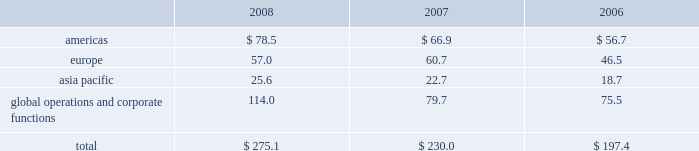Depreciation and amortization included in operating segment profit for the years ended december 31 , 2008 , 2007 and 2006 was as follows ( in millions ) : .
15 .
Leases future minimum rental commitments under non- cancelable operating leases in effect as of december 31 , 2008 were $ 38.2 million for 2009 , $ 30.1 million for 2010 , $ 20.9 million for 2011 , $ 15.9 million for 2012 , $ 14.3 million for 2013 and $ 29.9 million thereafter .
Total rent expense for the years ended december 31 , 2008 , 2007 and 2006 aggregated $ 41.4 million , $ 37.1 million and $ 31.1 million , respectively .
16 .
Commitments and contingencies intellectual property and product liability-related litigation in july 2008 , we temporarily suspended marketing and distribution of the durom bb acetabular component ( durom cup ) in the u.s .
To allow us to update product labeling to provide more detailed surgical technique instructions to surgeons and implement a surgical training program in the u.s .
Following our announcement , product liability lawsuits and other claims have been asserted against us , some of which we have settled .
There are a number of claims still pending and we expect additional claims will be submitted .
We recorded a provision of $ 47.5 million in the third quarter of 2008 , representing management 2019s estimate of these durom cup-related claims .
We increased that provision by $ 21.5 million in the fourth quarter of 2008 .
The provision is limited to revisions within two years of an original surgery that occurred prior to july 2008 .
These parameters are consistent with our data which indicates that cup loosenings associated with surgical technique are most likely to occur within that time period .
Any claims received outside of these defined parameters will be managed in the normal course and reflected in our standard product liability accruals .
On february 15 , 2005 , howmedica osteonics corp .
Filed an action against us and an unrelated party in the united states district court for the district of new jersey alleging infringement of u.s .
Patent nos .
6174934 ; 6372814 ; 6664308 ; and 6818020 .
On june 13 , 2007 , the court granted our motion for summary judgment on the invalidity of the asserted claims of u.s .
Patent nos .
6174934 ; 6372814 ; and 6664308 by ruling that all of the asserted claims are invalid for indefiniteness .
On august 19 , 2008 , the court granted our motion for summary judgment of non- infringement of certain claims of u.s .
Patent no .
6818020 , reducing the number of claims at issue in the suit to five .
We continue to believe that our defenses against infringement of the remaining claims are valid and meritorious , and we intend to defend this lawsuit vigorously .
In addition to certain claims related to the durom cup discussed above , we are also subject to product liability and other claims and lawsuits arising in the ordinary course of business , for which we maintain insurance , subject to self- insured retention limits .
We establish accruals for product liability and other claims in conjunction with outside counsel based on current information and historical settlement information for open claims , related fees and claims incurred but not reported .
While it is not possible to predict with certainty the outcome of these cases , it is the opinion of management that , upon ultimate resolution , liabilities from these cases in excess of those recorded , if any , will not have a material adverse effect on our consolidated financial position , results of operations or cash flows .
Government investigations in march 2005 , the u.s .
Department of justice through the u.s .
Attorney 2019s office in newark , new jersey commenced an investigation of us and four other orthopaedic companies pertaining to consulting contracts , professional service agreements and other agreements by which remuneration is provided to orthopaedic surgeons .
On september 27 , 2007 , we reached a settlement with the government to resolve all claims related to this investigation .
As part of the settlement , we entered into a settlement agreement with the u.s .
Through the u.s .
Department of justice and the office of inspector general of the department of health and human services ( the 201coig-hhs 201d ) .
In addition , we entered into a deferred prosecution agreement ( the 201cdpa 201d ) with the u.s .
Attorney 2019s office for the district of new jersey ( the 201cu.s .
Attorney 201d ) and a corporate integrity agreement ( the 201ccia 201d ) with the oig- hhs .
We did not admit any wrongdoing , plead guilty to any criminal charges or pay any criminal fines as part of the settlement .
We settled all civil and administrative claims related to the federal investigation by making a settlement payment to the u.s .
Government of $ 169.5 million .
Under the terms of the dpa , the u.s .
Attorney filed a criminal complaint in the u.s .
District court for the district of new jersey charging us with conspiracy to commit violations of the anti-kickback statute ( 42 u.s.c .
A7 1320a-7b ) during the years 2002 through 2006 .
The court deferred prosecution of the criminal complaint during the 18-month term of the dpa .
The u.s .
Attorney will seek dismissal of the criminal complaint after the 18-month period if we comply with the provisions of the dpa .
The dpa provides for oversight by a federally-appointed monitor .
Under the cia , which has a term of five years , we agreed , among other provisions , to continue the operation of our enhanced corporate compliance program , designed to promote compliance with federal healthcare program z i m m e r h o l d i n g s , i n c .
2 0 0 8 f o r m 1 0 - k a n n u a l r e p o r t notes to consolidated financial statements ( continued ) %%transmsg*** transmitting job : c48761 pcn : 060000000 ***%%pcmsg|60 |00012|yes|no|02/24/2009 06:10|0|0|page is valid , no graphics -- color : d| .
What was the percentage change in total rent expense from 2007 to 2008? 
Computations: ((41.4 - 37.1) / 37.1)
Answer: 0.1159. Depreciation and amortization included in operating segment profit for the years ended december 31 , 2008 , 2007 and 2006 was as follows ( in millions ) : .
15 .
Leases future minimum rental commitments under non- cancelable operating leases in effect as of december 31 , 2008 were $ 38.2 million for 2009 , $ 30.1 million for 2010 , $ 20.9 million for 2011 , $ 15.9 million for 2012 , $ 14.3 million for 2013 and $ 29.9 million thereafter .
Total rent expense for the years ended december 31 , 2008 , 2007 and 2006 aggregated $ 41.4 million , $ 37.1 million and $ 31.1 million , respectively .
16 .
Commitments and contingencies intellectual property and product liability-related litigation in july 2008 , we temporarily suspended marketing and distribution of the durom bb acetabular component ( durom cup ) in the u.s .
To allow us to update product labeling to provide more detailed surgical technique instructions to surgeons and implement a surgical training program in the u.s .
Following our announcement , product liability lawsuits and other claims have been asserted against us , some of which we have settled .
There are a number of claims still pending and we expect additional claims will be submitted .
We recorded a provision of $ 47.5 million in the third quarter of 2008 , representing management 2019s estimate of these durom cup-related claims .
We increased that provision by $ 21.5 million in the fourth quarter of 2008 .
The provision is limited to revisions within two years of an original surgery that occurred prior to july 2008 .
These parameters are consistent with our data which indicates that cup loosenings associated with surgical technique are most likely to occur within that time period .
Any claims received outside of these defined parameters will be managed in the normal course and reflected in our standard product liability accruals .
On february 15 , 2005 , howmedica osteonics corp .
Filed an action against us and an unrelated party in the united states district court for the district of new jersey alleging infringement of u.s .
Patent nos .
6174934 ; 6372814 ; 6664308 ; and 6818020 .
On june 13 , 2007 , the court granted our motion for summary judgment on the invalidity of the asserted claims of u.s .
Patent nos .
6174934 ; 6372814 ; and 6664308 by ruling that all of the asserted claims are invalid for indefiniteness .
On august 19 , 2008 , the court granted our motion for summary judgment of non- infringement of certain claims of u.s .
Patent no .
6818020 , reducing the number of claims at issue in the suit to five .
We continue to believe that our defenses against infringement of the remaining claims are valid and meritorious , and we intend to defend this lawsuit vigorously .
In addition to certain claims related to the durom cup discussed above , we are also subject to product liability and other claims and lawsuits arising in the ordinary course of business , for which we maintain insurance , subject to self- insured retention limits .
We establish accruals for product liability and other claims in conjunction with outside counsel based on current information and historical settlement information for open claims , related fees and claims incurred but not reported .
While it is not possible to predict with certainty the outcome of these cases , it is the opinion of management that , upon ultimate resolution , liabilities from these cases in excess of those recorded , if any , will not have a material adverse effect on our consolidated financial position , results of operations or cash flows .
Government investigations in march 2005 , the u.s .
Department of justice through the u.s .
Attorney 2019s office in newark , new jersey commenced an investigation of us and four other orthopaedic companies pertaining to consulting contracts , professional service agreements and other agreements by which remuneration is provided to orthopaedic surgeons .
On september 27 , 2007 , we reached a settlement with the government to resolve all claims related to this investigation .
As part of the settlement , we entered into a settlement agreement with the u.s .
Through the u.s .
Department of justice and the office of inspector general of the department of health and human services ( the 201coig-hhs 201d ) .
In addition , we entered into a deferred prosecution agreement ( the 201cdpa 201d ) with the u.s .
Attorney 2019s office for the district of new jersey ( the 201cu.s .
Attorney 201d ) and a corporate integrity agreement ( the 201ccia 201d ) with the oig- hhs .
We did not admit any wrongdoing , plead guilty to any criminal charges or pay any criminal fines as part of the settlement .
We settled all civil and administrative claims related to the federal investigation by making a settlement payment to the u.s .
Government of $ 169.5 million .
Under the terms of the dpa , the u.s .
Attorney filed a criminal complaint in the u.s .
District court for the district of new jersey charging us with conspiracy to commit violations of the anti-kickback statute ( 42 u.s.c .
A7 1320a-7b ) during the years 2002 through 2006 .
The court deferred prosecution of the criminal complaint during the 18-month term of the dpa .
The u.s .
Attorney will seek dismissal of the criminal complaint after the 18-month period if we comply with the provisions of the dpa .
The dpa provides for oversight by a federally-appointed monitor .
Under the cia , which has a term of five years , we agreed , among other provisions , to continue the operation of our enhanced corporate compliance program , designed to promote compliance with federal healthcare program z i m m e r h o l d i n g s , i n c .
2 0 0 8 f o r m 1 0 - k a n n u a l r e p o r t notes to consolidated financial statements ( continued ) %%transmsg*** transmitting job : c48761 pcn : 060000000 ***%%pcmsg|60 |00012|yes|no|02/24/2009 06:10|0|0|page is valid , no graphics -- color : d| .
What percent does total depreciation & amortization expenses increase between 2006 and 2008? 
Computations: ((275.1 / 197.4) - 1)
Answer: 0.39362. Depreciation and amortization included in operating segment profit for the years ended december 31 , 2008 , 2007 and 2006 was as follows ( in millions ) : .
15 .
Leases future minimum rental commitments under non- cancelable operating leases in effect as of december 31 , 2008 were $ 38.2 million for 2009 , $ 30.1 million for 2010 , $ 20.9 million for 2011 , $ 15.9 million for 2012 , $ 14.3 million for 2013 and $ 29.9 million thereafter .
Total rent expense for the years ended december 31 , 2008 , 2007 and 2006 aggregated $ 41.4 million , $ 37.1 million and $ 31.1 million , respectively .
16 .
Commitments and contingencies intellectual property and product liability-related litigation in july 2008 , we temporarily suspended marketing and distribution of the durom bb acetabular component ( durom cup ) in the u.s .
To allow us to update product labeling to provide more detailed surgical technique instructions to surgeons and implement a surgical training program in the u.s .
Following our announcement , product liability lawsuits and other claims have been asserted against us , some of which we have settled .
There are a number of claims still pending and we expect additional claims will be submitted .
We recorded a provision of $ 47.5 million in the third quarter of 2008 , representing management 2019s estimate of these durom cup-related claims .
We increased that provision by $ 21.5 million in the fourth quarter of 2008 .
The provision is limited to revisions within two years of an original surgery that occurred prior to july 2008 .
These parameters are consistent with our data which indicates that cup loosenings associated with surgical technique are most likely to occur within that time period .
Any claims received outside of these defined parameters will be managed in the normal course and reflected in our standard product liability accruals .
On february 15 , 2005 , howmedica osteonics corp .
Filed an action against us and an unrelated party in the united states district court for the district of new jersey alleging infringement of u.s .
Patent nos .
6174934 ; 6372814 ; 6664308 ; and 6818020 .
On june 13 , 2007 , the court granted our motion for summary judgment on the invalidity of the asserted claims of u.s .
Patent nos .
6174934 ; 6372814 ; and 6664308 by ruling that all of the asserted claims are invalid for indefiniteness .
On august 19 , 2008 , the court granted our motion for summary judgment of non- infringement of certain claims of u.s .
Patent no .
6818020 , reducing the number of claims at issue in the suit to five .
We continue to believe that our defenses against infringement of the remaining claims are valid and meritorious , and we intend to defend this lawsuit vigorously .
In addition to certain claims related to the durom cup discussed above , we are also subject to product liability and other claims and lawsuits arising in the ordinary course of business , for which we maintain insurance , subject to self- insured retention limits .
We establish accruals for product liability and other claims in conjunction with outside counsel based on current information and historical settlement information for open claims , related fees and claims incurred but not reported .
While it is not possible to predict with certainty the outcome of these cases , it is the opinion of management that , upon ultimate resolution , liabilities from these cases in excess of those recorded , if any , will not have a material adverse effect on our consolidated financial position , results of operations or cash flows .
Government investigations in march 2005 , the u.s .
Department of justice through the u.s .
Attorney 2019s office in newark , new jersey commenced an investigation of us and four other orthopaedic companies pertaining to consulting contracts , professional service agreements and other agreements by which remuneration is provided to orthopaedic surgeons .
On september 27 , 2007 , we reached a settlement with the government to resolve all claims related to this investigation .
As part of the settlement , we entered into a settlement agreement with the u.s .
Through the u.s .
Department of justice and the office of inspector general of the department of health and human services ( the 201coig-hhs 201d ) .
In addition , we entered into a deferred prosecution agreement ( the 201cdpa 201d ) with the u.s .
Attorney 2019s office for the district of new jersey ( the 201cu.s .
Attorney 201d ) and a corporate integrity agreement ( the 201ccia 201d ) with the oig- hhs .
We did not admit any wrongdoing , plead guilty to any criminal charges or pay any criminal fines as part of the settlement .
We settled all civil and administrative claims related to the federal investigation by making a settlement payment to the u.s .
Government of $ 169.5 million .
Under the terms of the dpa , the u.s .
Attorney filed a criminal complaint in the u.s .
District court for the district of new jersey charging us with conspiracy to commit violations of the anti-kickback statute ( 42 u.s.c .
A7 1320a-7b ) during the years 2002 through 2006 .
The court deferred prosecution of the criminal complaint during the 18-month term of the dpa .
The u.s .
Attorney will seek dismissal of the criminal complaint after the 18-month period if we comply with the provisions of the dpa .
The dpa provides for oversight by a federally-appointed monitor .
Under the cia , which has a term of five years , we agreed , among other provisions , to continue the operation of our enhanced corporate compliance program , designed to promote compliance with federal healthcare program z i m m e r h o l d i n g s , i n c .
2 0 0 8 f o r m 1 0 - k a n n u a l r e p o r t notes to consolidated financial statements ( continued ) %%transmsg*** transmitting job : c48761 pcn : 060000000 ***%%pcmsg|60 |00012|yes|no|02/24/2009 06:10|0|0|page is valid , no graphics -- color : d| .
What was the percentage change in total rent expense from 2006 to 2007? 
Computations: ((37.1 - 31.1) / 31.1)
Answer: 0.19293. 